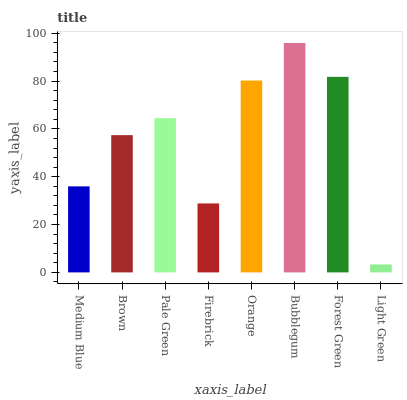Is Brown the minimum?
Answer yes or no. No. Is Brown the maximum?
Answer yes or no. No. Is Brown greater than Medium Blue?
Answer yes or no. Yes. Is Medium Blue less than Brown?
Answer yes or no. Yes. Is Medium Blue greater than Brown?
Answer yes or no. No. Is Brown less than Medium Blue?
Answer yes or no. No. Is Pale Green the high median?
Answer yes or no. Yes. Is Brown the low median?
Answer yes or no. Yes. Is Brown the high median?
Answer yes or no. No. Is Firebrick the low median?
Answer yes or no. No. 